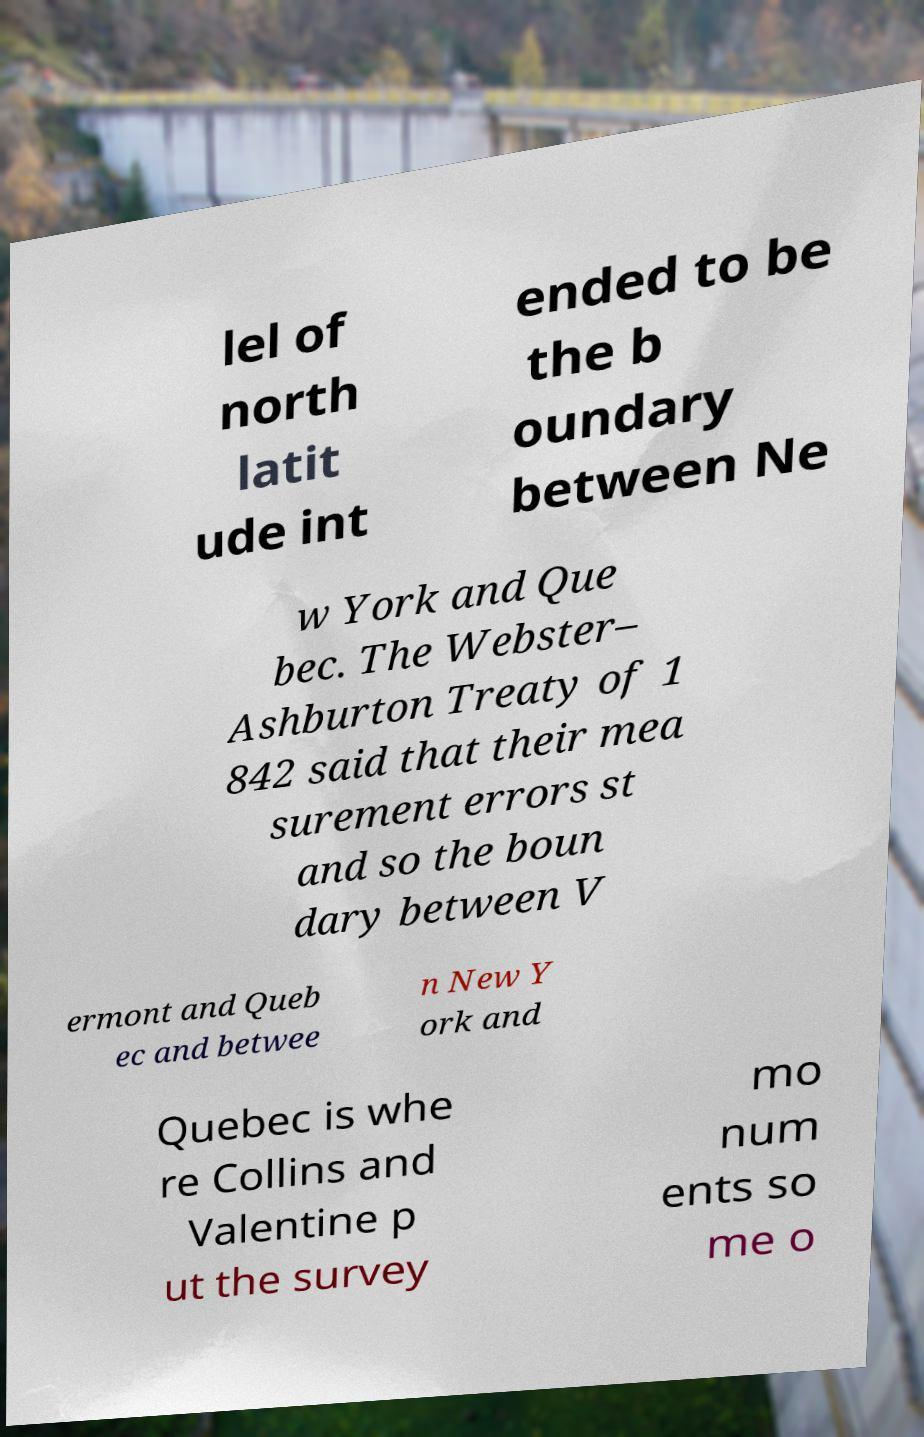Could you extract and type out the text from this image? lel of north latit ude int ended to be the b oundary between Ne w York and Que bec. The Webster– Ashburton Treaty of 1 842 said that their mea surement errors st and so the boun dary between V ermont and Queb ec and betwee n New Y ork and Quebec is whe re Collins and Valentine p ut the survey mo num ents so me o 